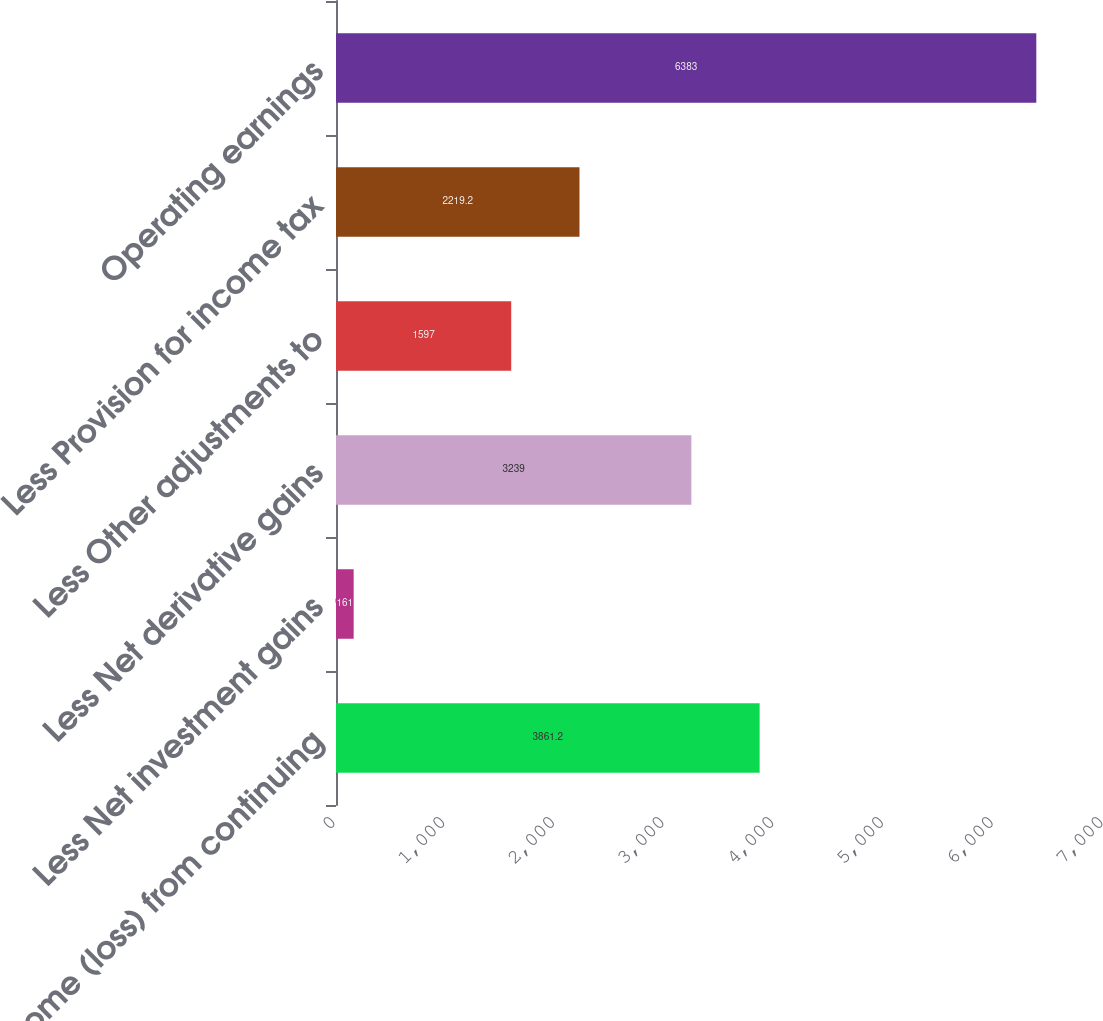Convert chart. <chart><loc_0><loc_0><loc_500><loc_500><bar_chart><fcel>Income (loss) from continuing<fcel>Less Net investment gains<fcel>Less Net derivative gains<fcel>Less Other adjustments to<fcel>Less Provision for income tax<fcel>Operating earnings<nl><fcel>3861.2<fcel>161<fcel>3239<fcel>1597<fcel>2219.2<fcel>6383<nl></chart> 